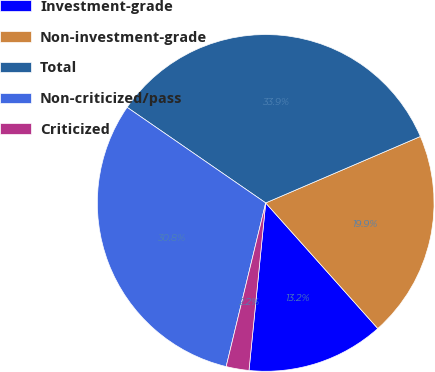Convert chart to OTSL. <chart><loc_0><loc_0><loc_500><loc_500><pie_chart><fcel>Investment-grade<fcel>Non-investment-grade<fcel>Total<fcel>Non-criticized/pass<fcel>Criticized<nl><fcel>13.18%<fcel>19.86%<fcel>33.93%<fcel>30.84%<fcel>2.19%<nl></chart> 